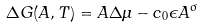Convert formula to latex. <formula><loc_0><loc_0><loc_500><loc_500>\Delta G ( A , T ) = A \Delta \mu - c _ { 0 } \epsilon A ^ { \sigma }</formula> 